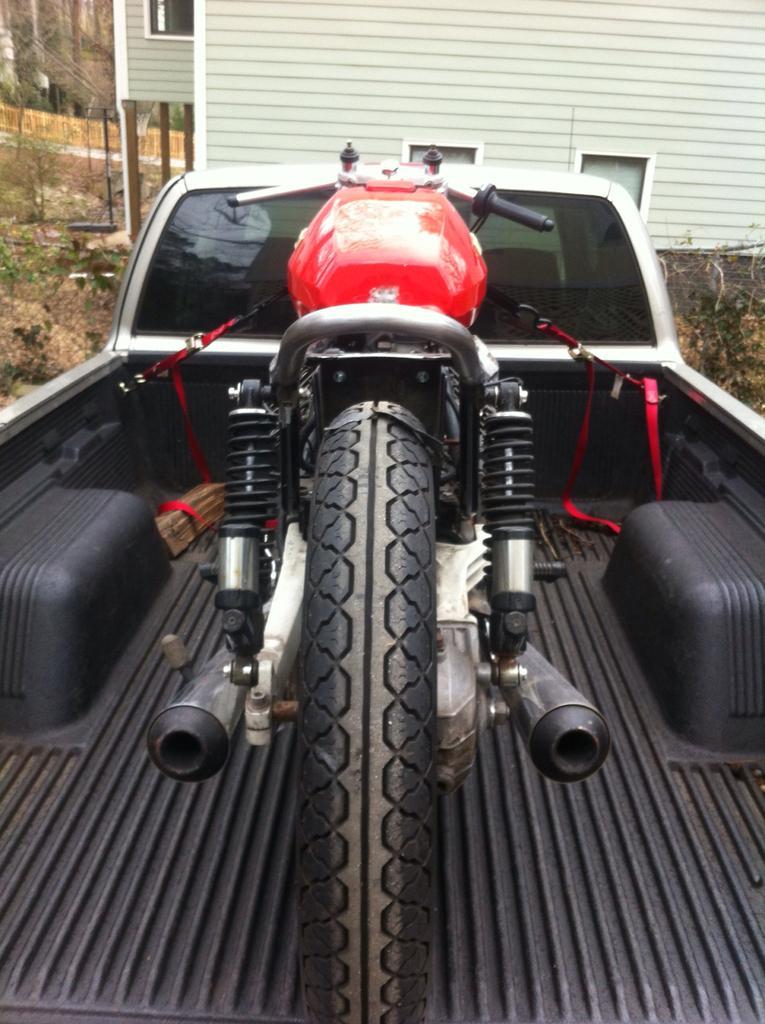Describe this image in one or two sentences. In the picture I can see the jeep vehicle and there is a motorcycle in the vehicle. In the background, I can see the house and glass windows. I can see the trees on the top left side. 